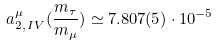Convert formula to latex. <formula><loc_0><loc_0><loc_500><loc_500>a ^ { \mu } _ { 2 , \, I V } ( \frac { m _ { \tau } } { m _ { \mu } } ) \simeq 7 . 8 0 7 ( 5 ) \cdot 1 0 ^ { - 5 }</formula> 